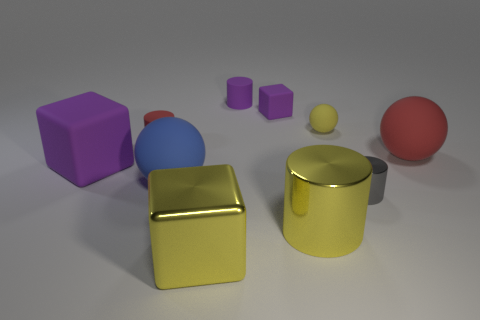Is the color of the shiny cylinder that is in front of the gray shiny thing the same as the big metallic block?
Your answer should be compact. Yes. How big is the red matte object that is on the right side of the cylinder that is to the left of the yellow metal cube?
Make the answer very short. Large. Is the number of large yellow shiny objects on the right side of the small purple matte block greater than the number of big gray rubber cubes?
Make the answer very short. Yes. Is the size of the metal object on the left side of the yellow metallic cylinder the same as the large red matte sphere?
Offer a terse response. Yes. There is a cube that is on the left side of the small matte block and behind the blue sphere; what is its color?
Keep it short and to the point. Purple. What is the shape of the red rubber thing that is the same size as the yellow ball?
Give a very brief answer. Cylinder. Are there any matte blocks that have the same color as the metal cube?
Offer a very short reply. No. Is the number of large purple rubber things in front of the yellow metallic cube the same as the number of small purple cylinders?
Ensure brevity in your answer.  No. Does the tiny cube have the same color as the big matte block?
Make the answer very short. Yes. What is the size of the cylinder that is both to the right of the small rubber block and behind the big yellow metal cylinder?
Provide a succinct answer. Small. 